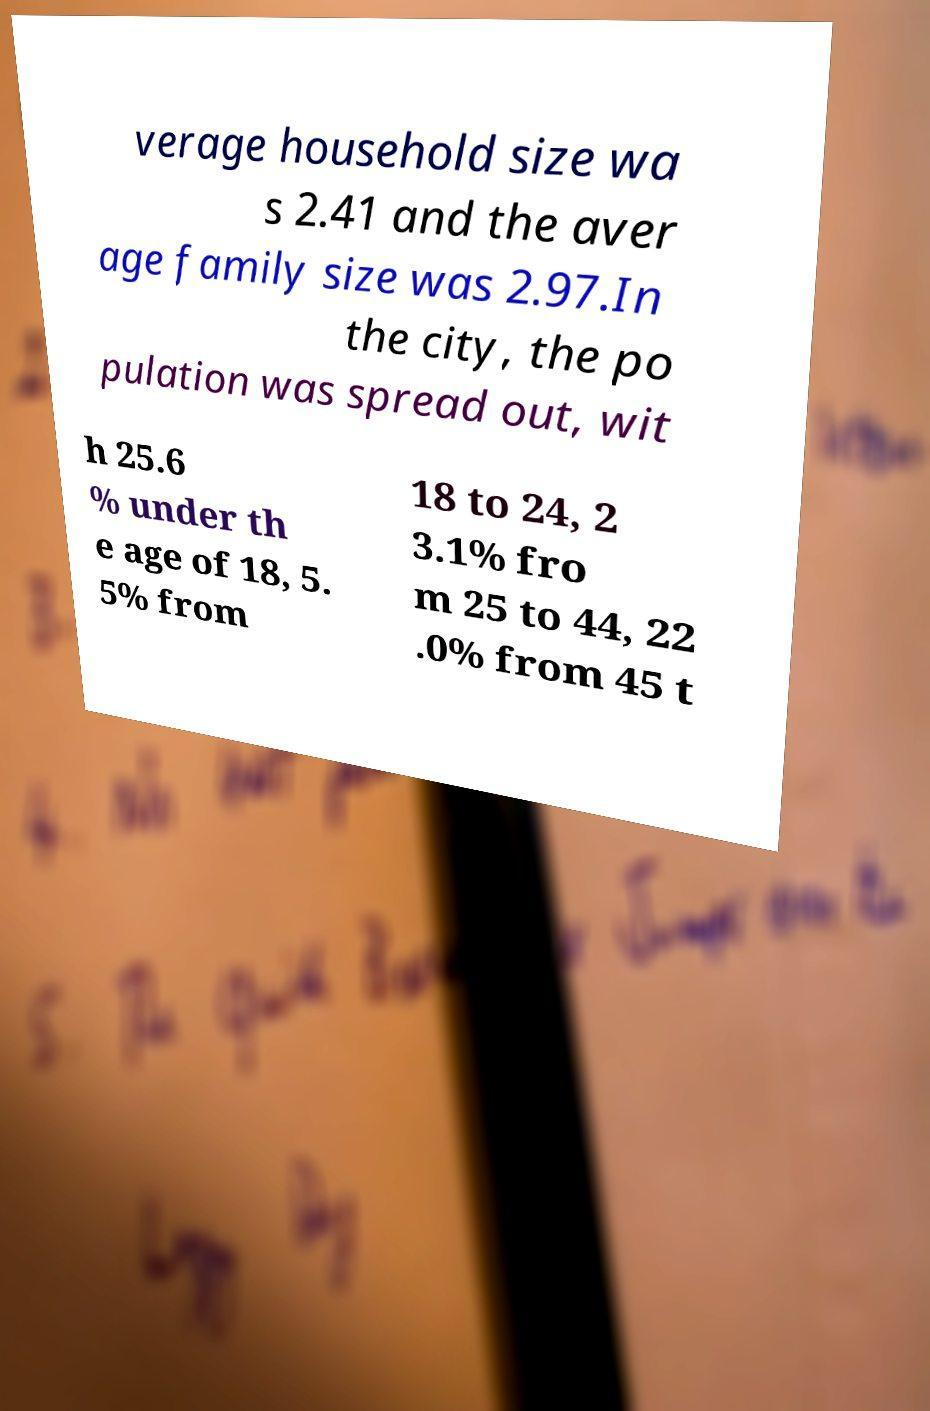There's text embedded in this image that I need extracted. Can you transcribe it verbatim? verage household size wa s 2.41 and the aver age family size was 2.97.In the city, the po pulation was spread out, wit h 25.6 % under th e age of 18, 5. 5% from 18 to 24, 2 3.1% fro m 25 to 44, 22 .0% from 45 t 